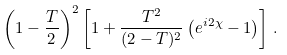Convert formula to latex. <formula><loc_0><loc_0><loc_500><loc_500>\left ( 1 - \frac { T } { 2 } \right ) ^ { 2 } \left [ 1 + \frac { T ^ { 2 } } { ( 2 - T ) ^ { 2 } } \left ( e ^ { i 2 \chi } - 1 \right ) \right ] \, .</formula> 